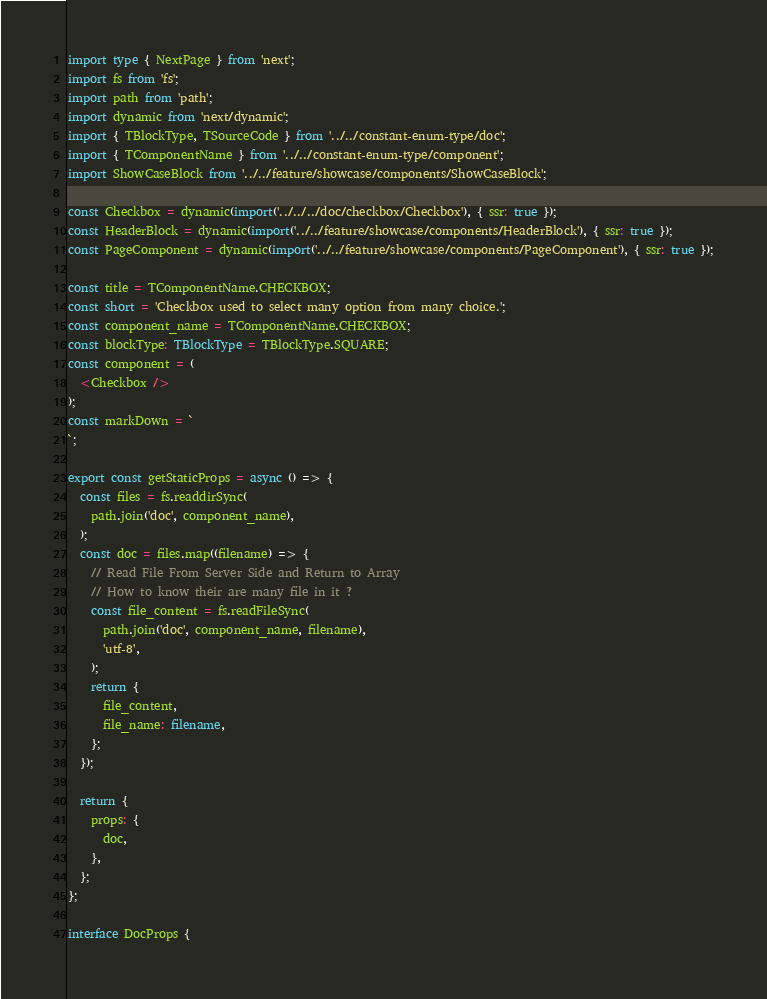<code> <loc_0><loc_0><loc_500><loc_500><_TypeScript_>import type { NextPage } from 'next';
import fs from 'fs';
import path from 'path';
import dynamic from 'next/dynamic';
import { TBlockType, TSourceCode } from '../../constant-enum-type/doc';
import { TComponentName } from '../../constant-enum-type/component';
import ShowCaseBlock from '../../feature/showcase/components/ShowCaseBlock';

const Checkbox = dynamic(import('../../../doc/checkbox/Checkbox'), { ssr: true });
const HeaderBlock = dynamic(import('../../feature/showcase/components/HeaderBlock'), { ssr: true });
const PageComponent = dynamic(import('../../feature/showcase/components/PageComponent'), { ssr: true });

const title = TComponentName.CHECKBOX;
const short = 'Checkbox used to select many option from many choice.';
const component_name = TComponentName.CHECKBOX;
const blockType: TBlockType = TBlockType.SQUARE;
const component = (
  <Checkbox />
);
const markDown = `
`;

export const getStaticProps = async () => {
  const files = fs.readdirSync(
    path.join('doc', component_name),
  );
  const doc = files.map((filename) => {
    // Read File From Server Side and Return to Array
    // How to know their are many file in it ?
    const file_content = fs.readFileSync(
      path.join('doc', component_name, filename),
      'utf-8',
    );
    return {
      file_content,
      file_name: filename,
    };
  });

  return {
    props: {
      doc,
    },
  };
};

interface DocProps {</code> 